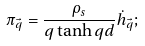<formula> <loc_0><loc_0><loc_500><loc_500>\pi _ { \vec { q } } = \frac { \rho _ { s } } { q \tanh q d } \dot { h } _ { \vec { q } } ;</formula> 